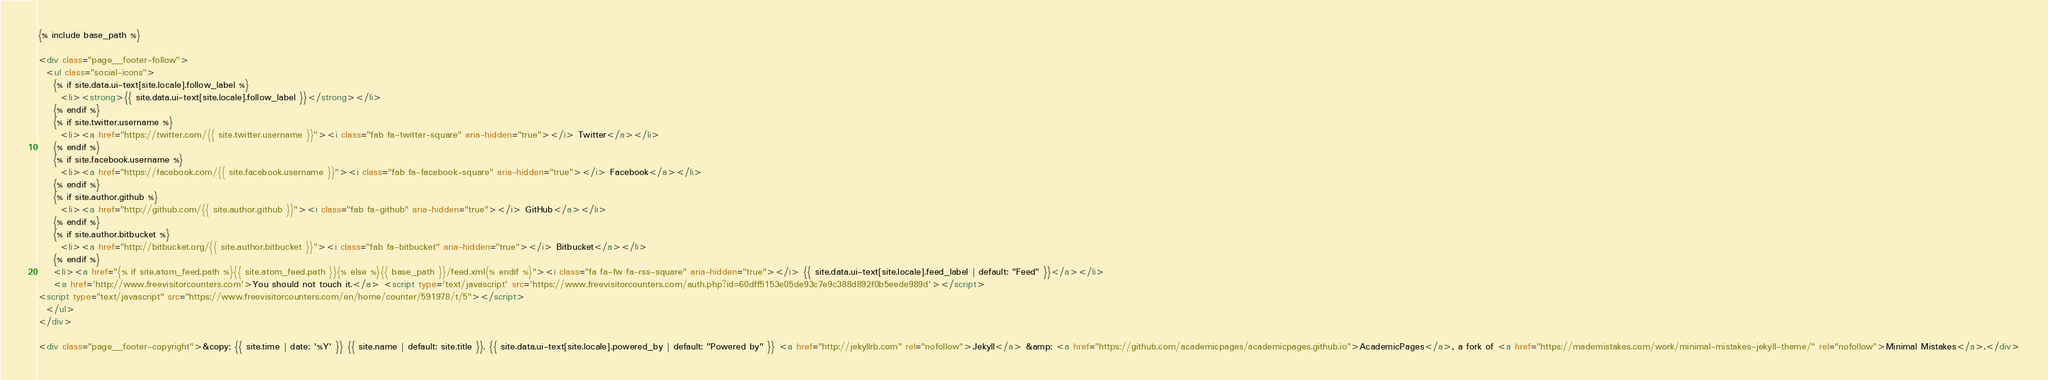<code> <loc_0><loc_0><loc_500><loc_500><_HTML_>{% include base_path %}

<div class="page__footer-follow">
  <ul class="social-icons">
    {% if site.data.ui-text[site.locale].follow_label %}
      <li><strong>{{ site.data.ui-text[site.locale].follow_label }}</strong></li>
    {% endif %}
    {% if site.twitter.username %}
      <li><a href="https://twitter.com/{{ site.twitter.username }}"><i class="fab fa-twitter-square" aria-hidden="true"></i> Twitter</a></li>
    {% endif %}
    {% if site.facebook.username %}
      <li><a href="https://facebook.com/{{ site.facebook.username }}"><i class="fab fa-facebook-square" aria-hidden="true"></i> Facebook</a></li>
    {% endif %}
    {% if site.author.github %}
      <li><a href="http://github.com/{{ site.author.github }}"><i class="fab fa-github" aria-hidden="true"></i> GitHub</a></li>
    {% endif %}
    {% if site.author.bitbucket %}
      <li><a href="http://bitbucket.org/{{ site.author.bitbucket }}"><i class="fab fa-bitbucket" aria-hidden="true"></i> Bitbucket</a></li>
    {% endif %}
    <li><a href="{% if site.atom_feed.path %}{{ site.atom_feed.path }}{% else %}{{ base_path }}/feed.xml{% endif %}"><i class="fa fa-fw fa-rss-square" aria-hidden="true"></i> {{ site.data.ui-text[site.locale].feed_label | default: "Feed" }}</a></li>
    <a href='http://www.freevisitorcounters.com'>You should not touch it.</a> <script type='text/javascript' src='https://www.freevisitorcounters.com/auth.php?id=60dff5153e05de93c7e9c388d892f0b5eede989d'></script>
<script type="text/javascript" src="https://www.freevisitorcounters.com/en/home/counter/591978/t/5"></script>
  </ul>
</div>

<div class="page__footer-copyright">&copy; {{ site.time | date: '%Y' }} {{ site.name | default: site.title }}. {{ site.data.ui-text[site.locale].powered_by | default: "Powered by" }} <a href="http://jekyllrb.com" rel="nofollow">Jekyll</a> &amp; <a href="https://github.com/academicpages/academicpages.github.io">AcademicPages</a>, a fork of <a href="https://mademistakes.com/work/minimal-mistakes-jekyll-theme/" rel="nofollow">Minimal Mistakes</a>.</div>
</code> 